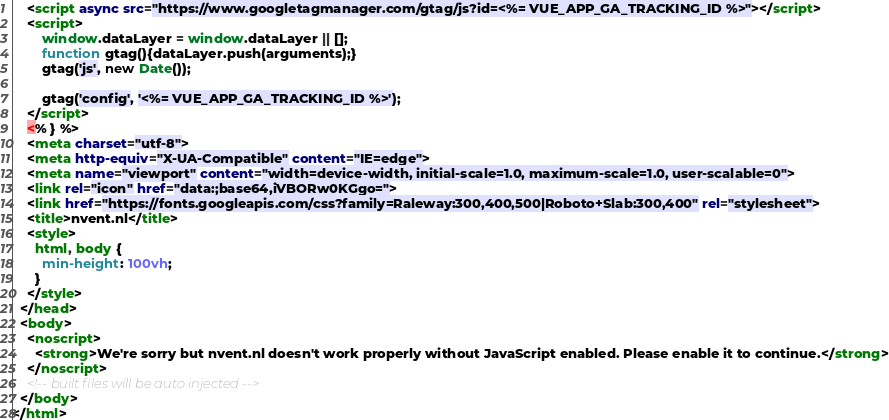Convert code to text. <code><loc_0><loc_0><loc_500><loc_500><_HTML_>    <script async src="https://www.googletagmanager.com/gtag/js?id=<%= VUE_APP_GA_TRACKING_ID %>"></script>
    <script>
        window.dataLayer = window.dataLayer || [];
        function gtag(){dataLayer.push(arguments);}
        gtag('js', new Date());

        gtag('config', '<%= VUE_APP_GA_TRACKING_ID %>');
    </script>
    <% } %>
    <meta charset="utf-8">
    <meta http-equiv="X-UA-Compatible" content="IE=edge">
    <meta name="viewport" content="width=device-width, initial-scale=1.0, maximum-scale=1.0, user-scalable=0">
    <link rel="icon" href="data:;base64,iVBORw0KGgo=">
    <link href="https://fonts.googleapis.com/css?family=Raleway:300,400,500|Roboto+Slab:300,400" rel="stylesheet">
    <title>nvent.nl</title>
    <style>
      html, body {
        min-height: 100vh;
      }
    </style>
  </head>
  <body>
    <noscript>
      <strong>We're sorry but nvent.nl doesn't work properly without JavaScript enabled. Please enable it to continue.</strong>
    </noscript>
    <!-- built files will be auto injected -->
  </body>
</html>
</code> 